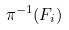Convert formula to latex. <formula><loc_0><loc_0><loc_500><loc_500>\pi ^ { - 1 } ( F _ { i } )</formula> 